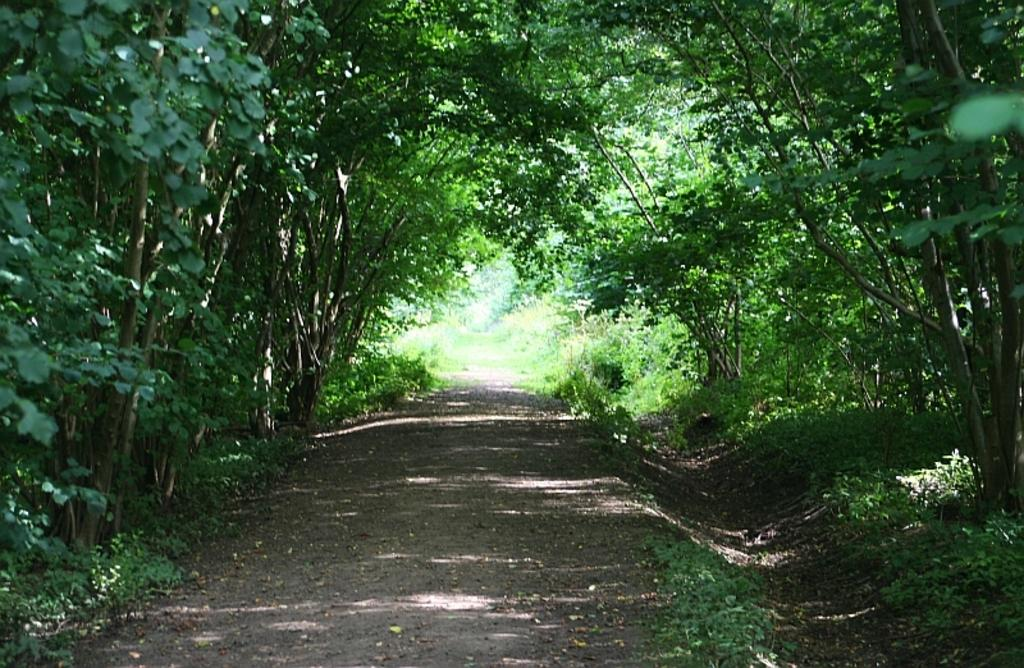What is located at the center of the image? There is a road at the center of the image. What type of vegetation is on the right side of the image? There are trees on the right side of the image. What type of vegetation is on the left side of the image? There are trees on the left side of the image. Where is the kettle located in the image? There is no kettle present in the image. Is there any water visible in the image? There is no water visible in the image. What type of crook can be seen in the image? There is no crook present in the image. 